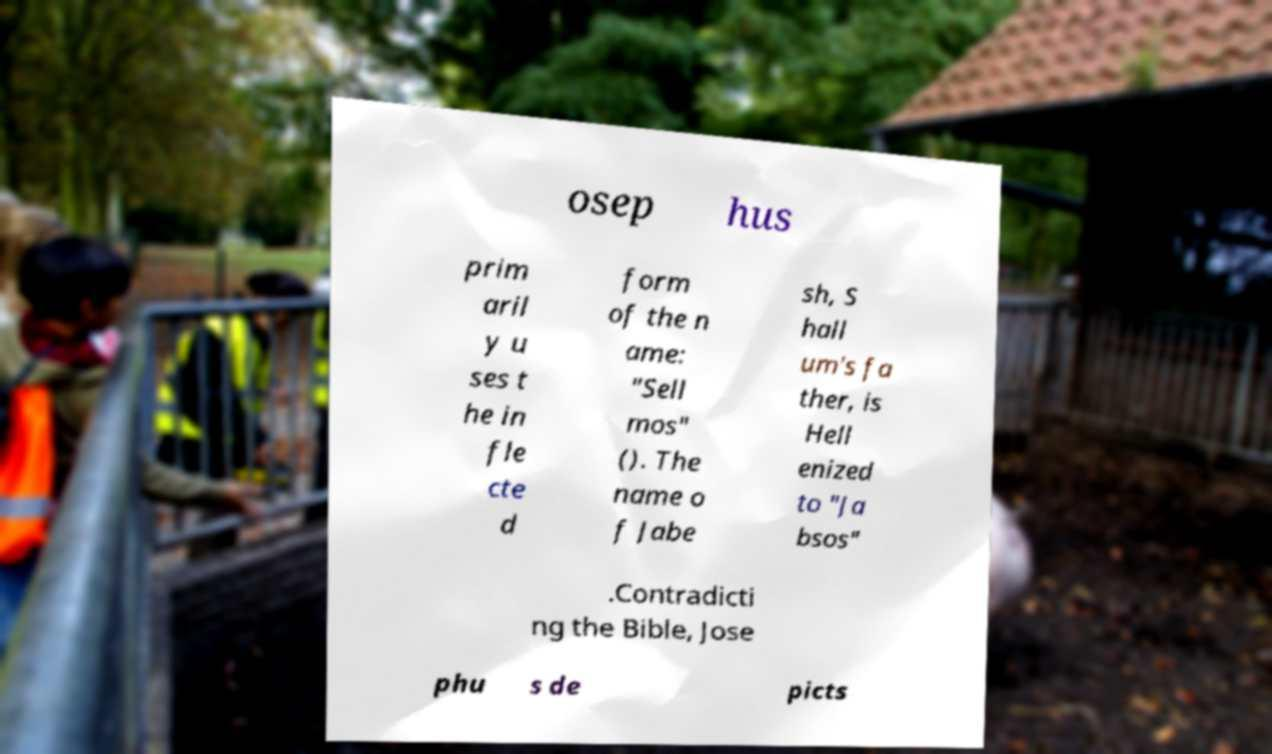What messages or text are displayed in this image? I need them in a readable, typed format. osep hus prim aril y u ses t he in fle cte d form of the n ame: "Sell mos" (). The name o f Jabe sh, S hall um's fa ther, is Hell enized to "Ja bsos" .Contradicti ng the Bible, Jose phu s de picts 